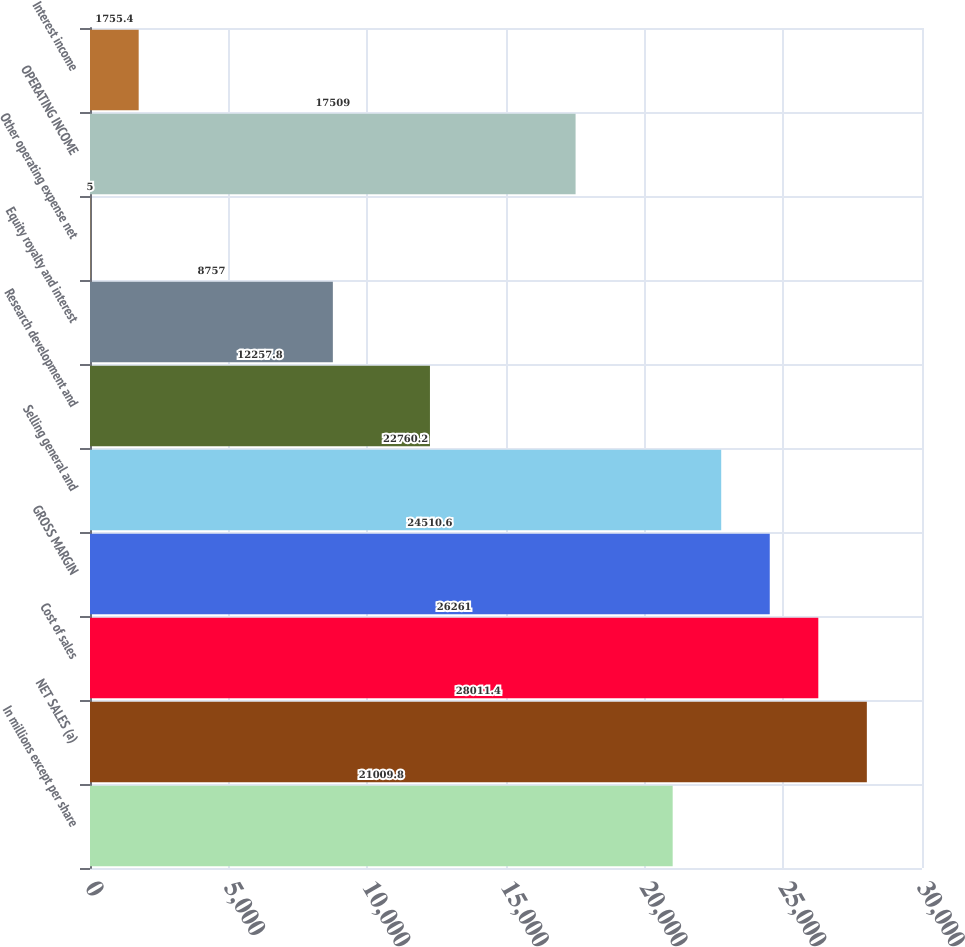<chart> <loc_0><loc_0><loc_500><loc_500><bar_chart><fcel>In millions except per share<fcel>NET SALES (a)<fcel>Cost of sales<fcel>GROSS MARGIN<fcel>Selling general and<fcel>Research development and<fcel>Equity royalty and interest<fcel>Other operating expense net<fcel>OPERATING INCOME<fcel>Interest income<nl><fcel>21009.8<fcel>28011.4<fcel>26261<fcel>24510.6<fcel>22760.2<fcel>12257.8<fcel>8757<fcel>5<fcel>17509<fcel>1755.4<nl></chart> 